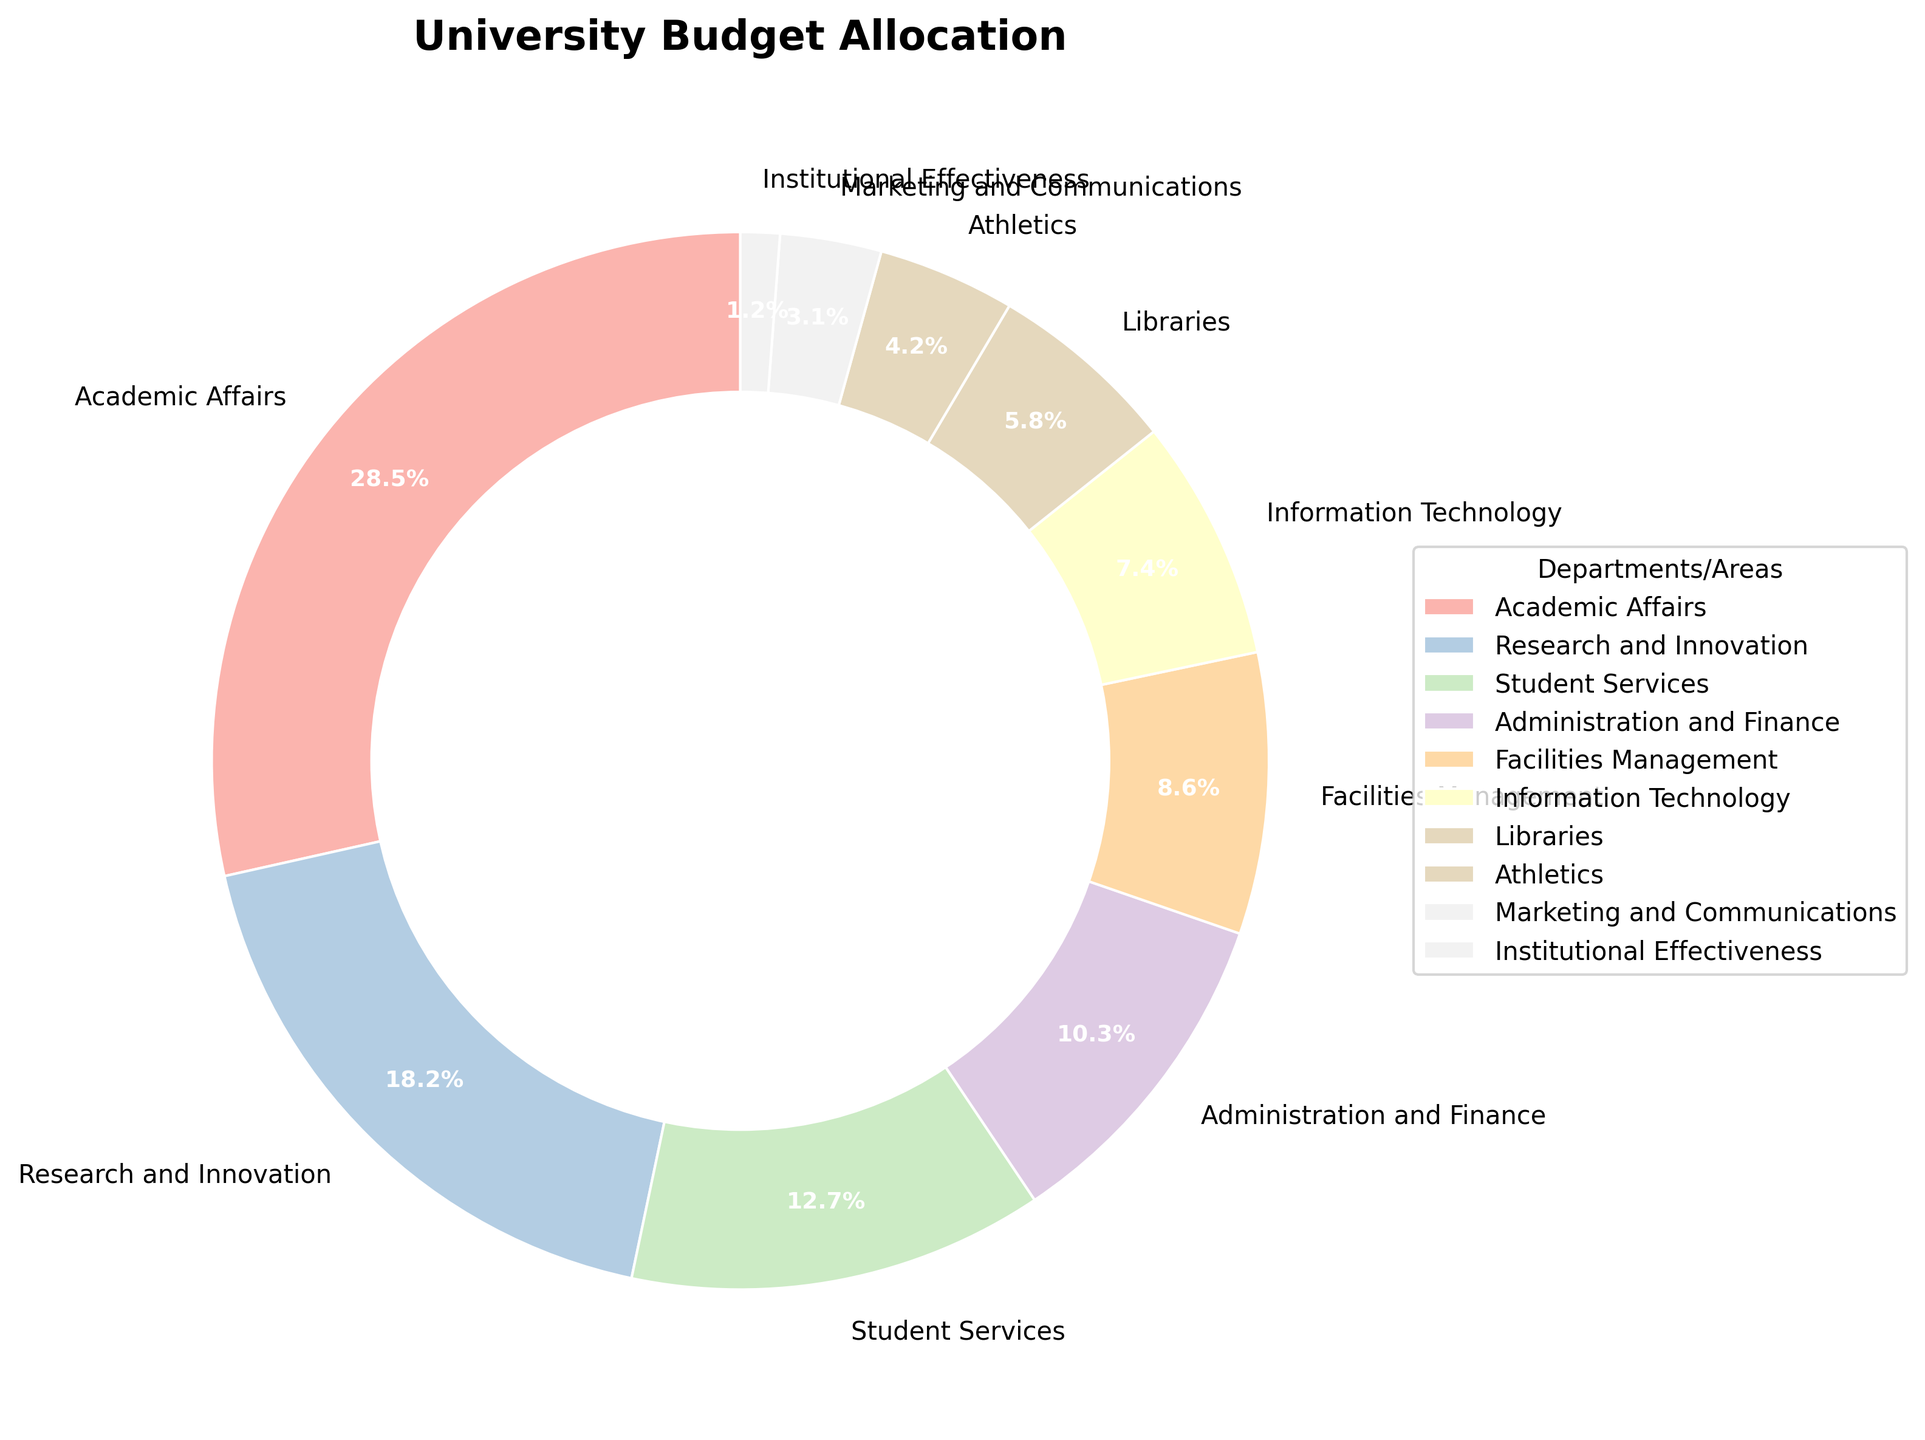Which department receives the highest percentage of the university budget? The pie chart shows the distribution of the university budget, and we observe that the largest sector corresponds to Academic Affairs.
Answer: Academic Affairs Which department has the lowest share in the university budget? Examination of the pie chart reveals that the smallest sector is labeled as Institutional Effectiveness.
Answer: Institutional Effectiveness How much more percentage of the budget is allocated to Academic Affairs compared to Student Services? According to the pie chart, Academic Affairs has 28.5% of the budget, and Student Services has 12.7%. The difference is 28.5% - 12.7% = 15.8%.
Answer: 15.8% Do Research and Innovation and Information Technology combined receive a higher budget percentage than Academic Affairs alone? Research and Innovation has 18.2% and Information Technology has 7.4%. Combined, this is 18.2% + 7.4% = 25.6%. Academic Affairs alone has 28.5%, which is higher.
Answer: No What is the average budget percentage allocated to Administration and Finance, Facilities Management, and Libraries? Adding the percentages for Administration and Finance (10.3%), Facilities Management (8.6%), and Libraries (5.8%) gives 10.3% + 8.6% + 5.8% = 24.7%. The average is 24.7% / 3 ≈ 8.2%.
Answer: 8.2% Which receives a greater budget percentage, Libraries or Marketing and Communications? From the pie chart, Libraries receive 5.8% of the budget, while Marketing and Communications receive 3.1%. Thus, Libraries receive a greater percentage.
Answer: Libraries Compare the total budget allocation percentage of Athletics and Institutional Effectiveness to that of Information Technology. Athletics has 4.2% and Institutional Effectiveness has 1.2%. Together, they have 4.2% + 1.2% = 5.4%. Information Technology has 7.4%, which is higher.
Answer: Information Technology Is the sum of Administration and Finance and Facilities Management more than 20%? Adding the percentages of Administration and Finance (10.3%) and Facilities Management (8.6%) gives 10.3% + 8.6% = 18.9%, which is less than 20%.
Answer: No 